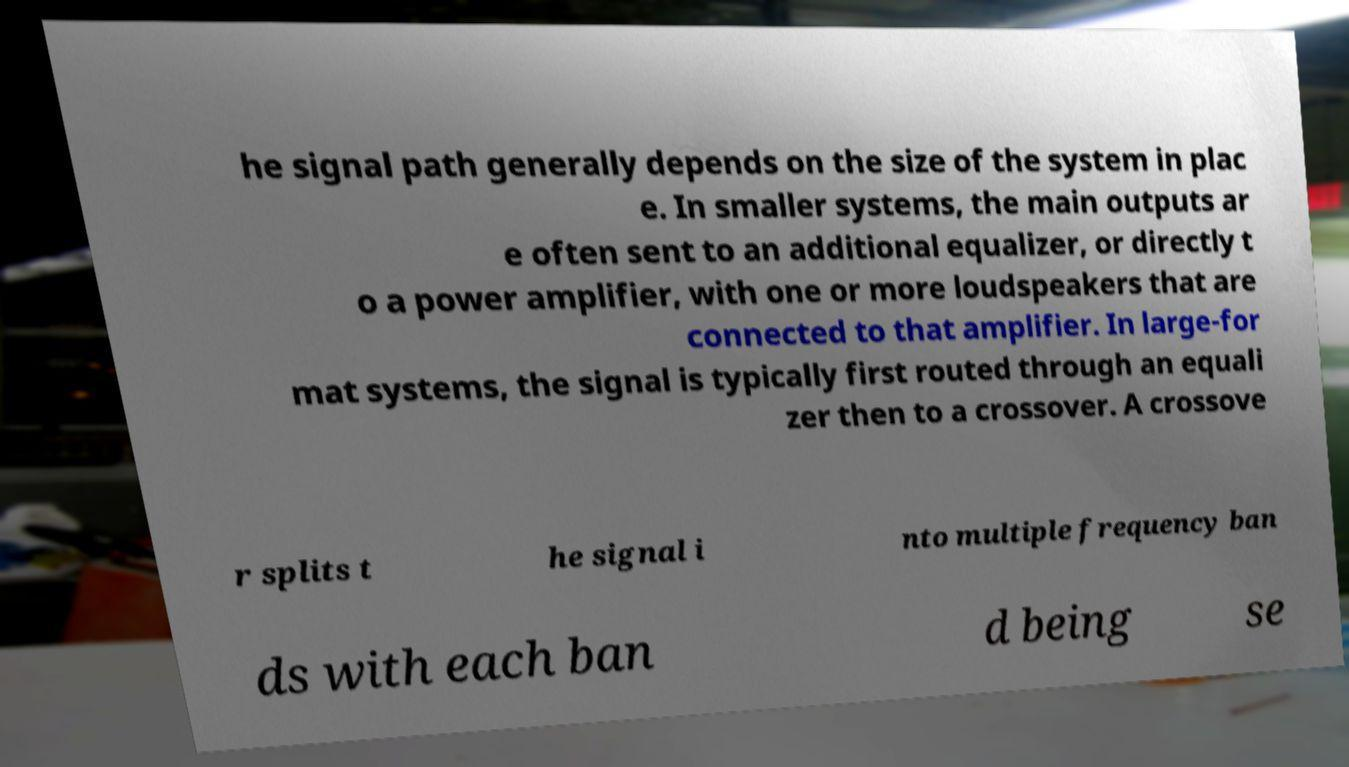For documentation purposes, I need the text within this image transcribed. Could you provide that? he signal path generally depends on the size of the system in plac e. In smaller systems, the main outputs ar e often sent to an additional equalizer, or directly t o a power amplifier, with one or more loudspeakers that are connected to that amplifier. In large-for mat systems, the signal is typically first routed through an equali zer then to a crossover. A crossove r splits t he signal i nto multiple frequency ban ds with each ban d being se 